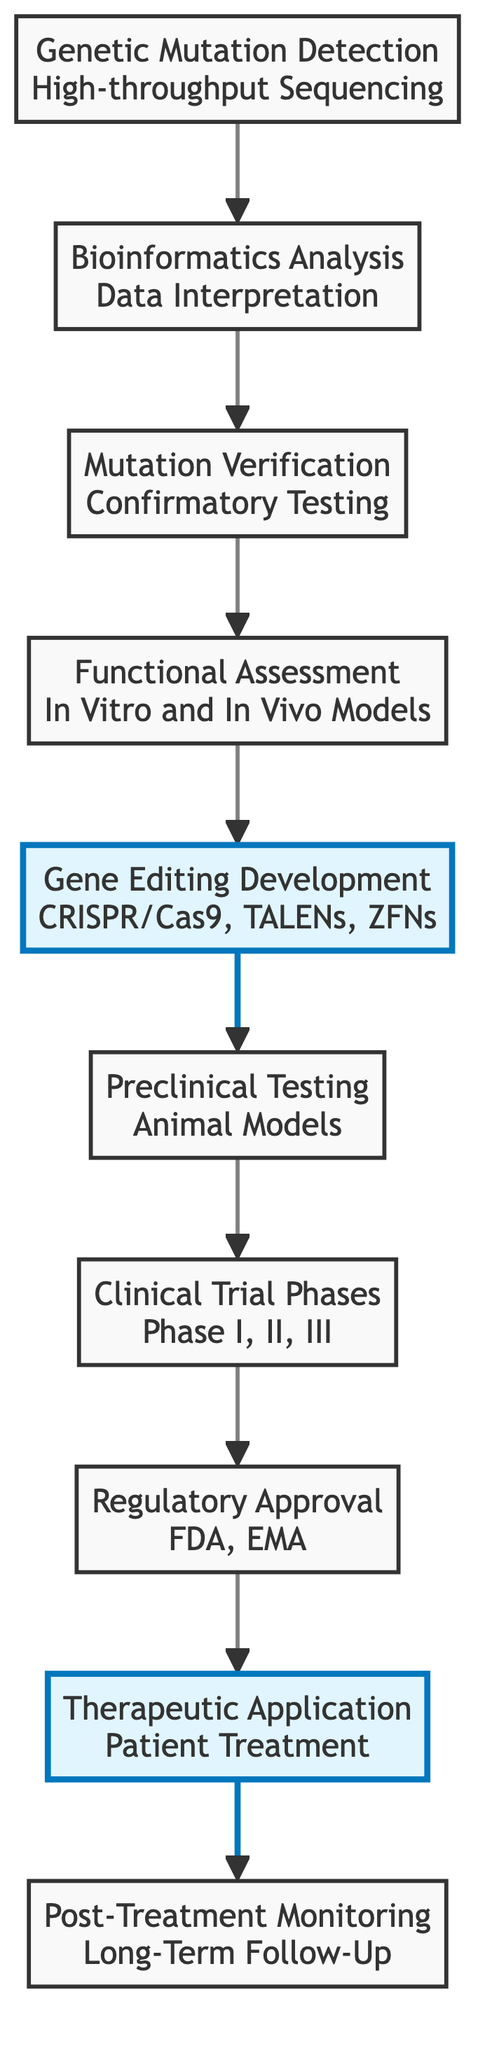What is the first step in the pathway for gene therapy? The diagram shows that the first step is "Genetic Mutation Detection" which involves high-throughput sequencing.
Answer: Genetic Mutation Detection How many total nodes are there in the diagram? By counting each distinct step in the flowchart from "Genetic Mutation Detection" to "Post-Treatment Monitoring," there are a total of 10 nodes.
Answer: 10 What follows after "Bioinformatics Analysis"? The flowchart indicates that the step following "Bioinformatics Analysis" is "Mutation Verification."
Answer: Mutation Verification Which steps are highlighted in the diagram? The diagram highlights "Gene Editing Development" and "Regulatory Approval," indicating their importance in the overall process.
Answer: Gene Editing Development, Regulatory Approval What is the last step in this pathway? The last step shown in the diagram is "Post-Treatment Monitoring," which comes after administering gene therapy to patients.
Answer: Post-Treatment Monitoring How many phases are included in the Clinical Trial? The diagram specifies that there are three phases in the Clinical Trial: Phase I, II, and III.
Answer: Three What is the purpose of "Functional Assessment"? "Functional Assessment" is conducted to understand the impact of the mutation through studies in cell lines or model organisms, as stated in the diagram description.
Answer: Understand impact of the mutation What is the primary role of "Preclinical Testing"? The role of "Preclinical Testing" is to test gene editing tools in relevant animal models to ensure efficacy and safety before moving to human trials.
Answer: Ensure efficacy and safety What is necessary before "Therapeutic Application"? The diagram indicates that "Regulatory Approval" is necessary before administering the gene therapy to patients.
Answer: Regulatory Approval Which techniques are mentioned in the "Gene Editing Development" step? The techniques mentioned include CRISPR/Cas9, TALENs, and ZFNs as tools for correcting identified mutations.
Answer: CRISPR/Cas9, TALENs, ZFNs 